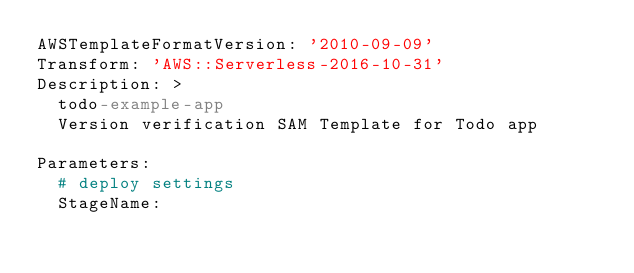Convert code to text. <code><loc_0><loc_0><loc_500><loc_500><_YAML_>AWSTemplateFormatVersion: '2010-09-09'
Transform: 'AWS::Serverless-2016-10-31'
Description: >
  todo-example-app
  Version verification SAM Template for Todo app

Parameters:
  # deploy settings
  StageName:</code> 